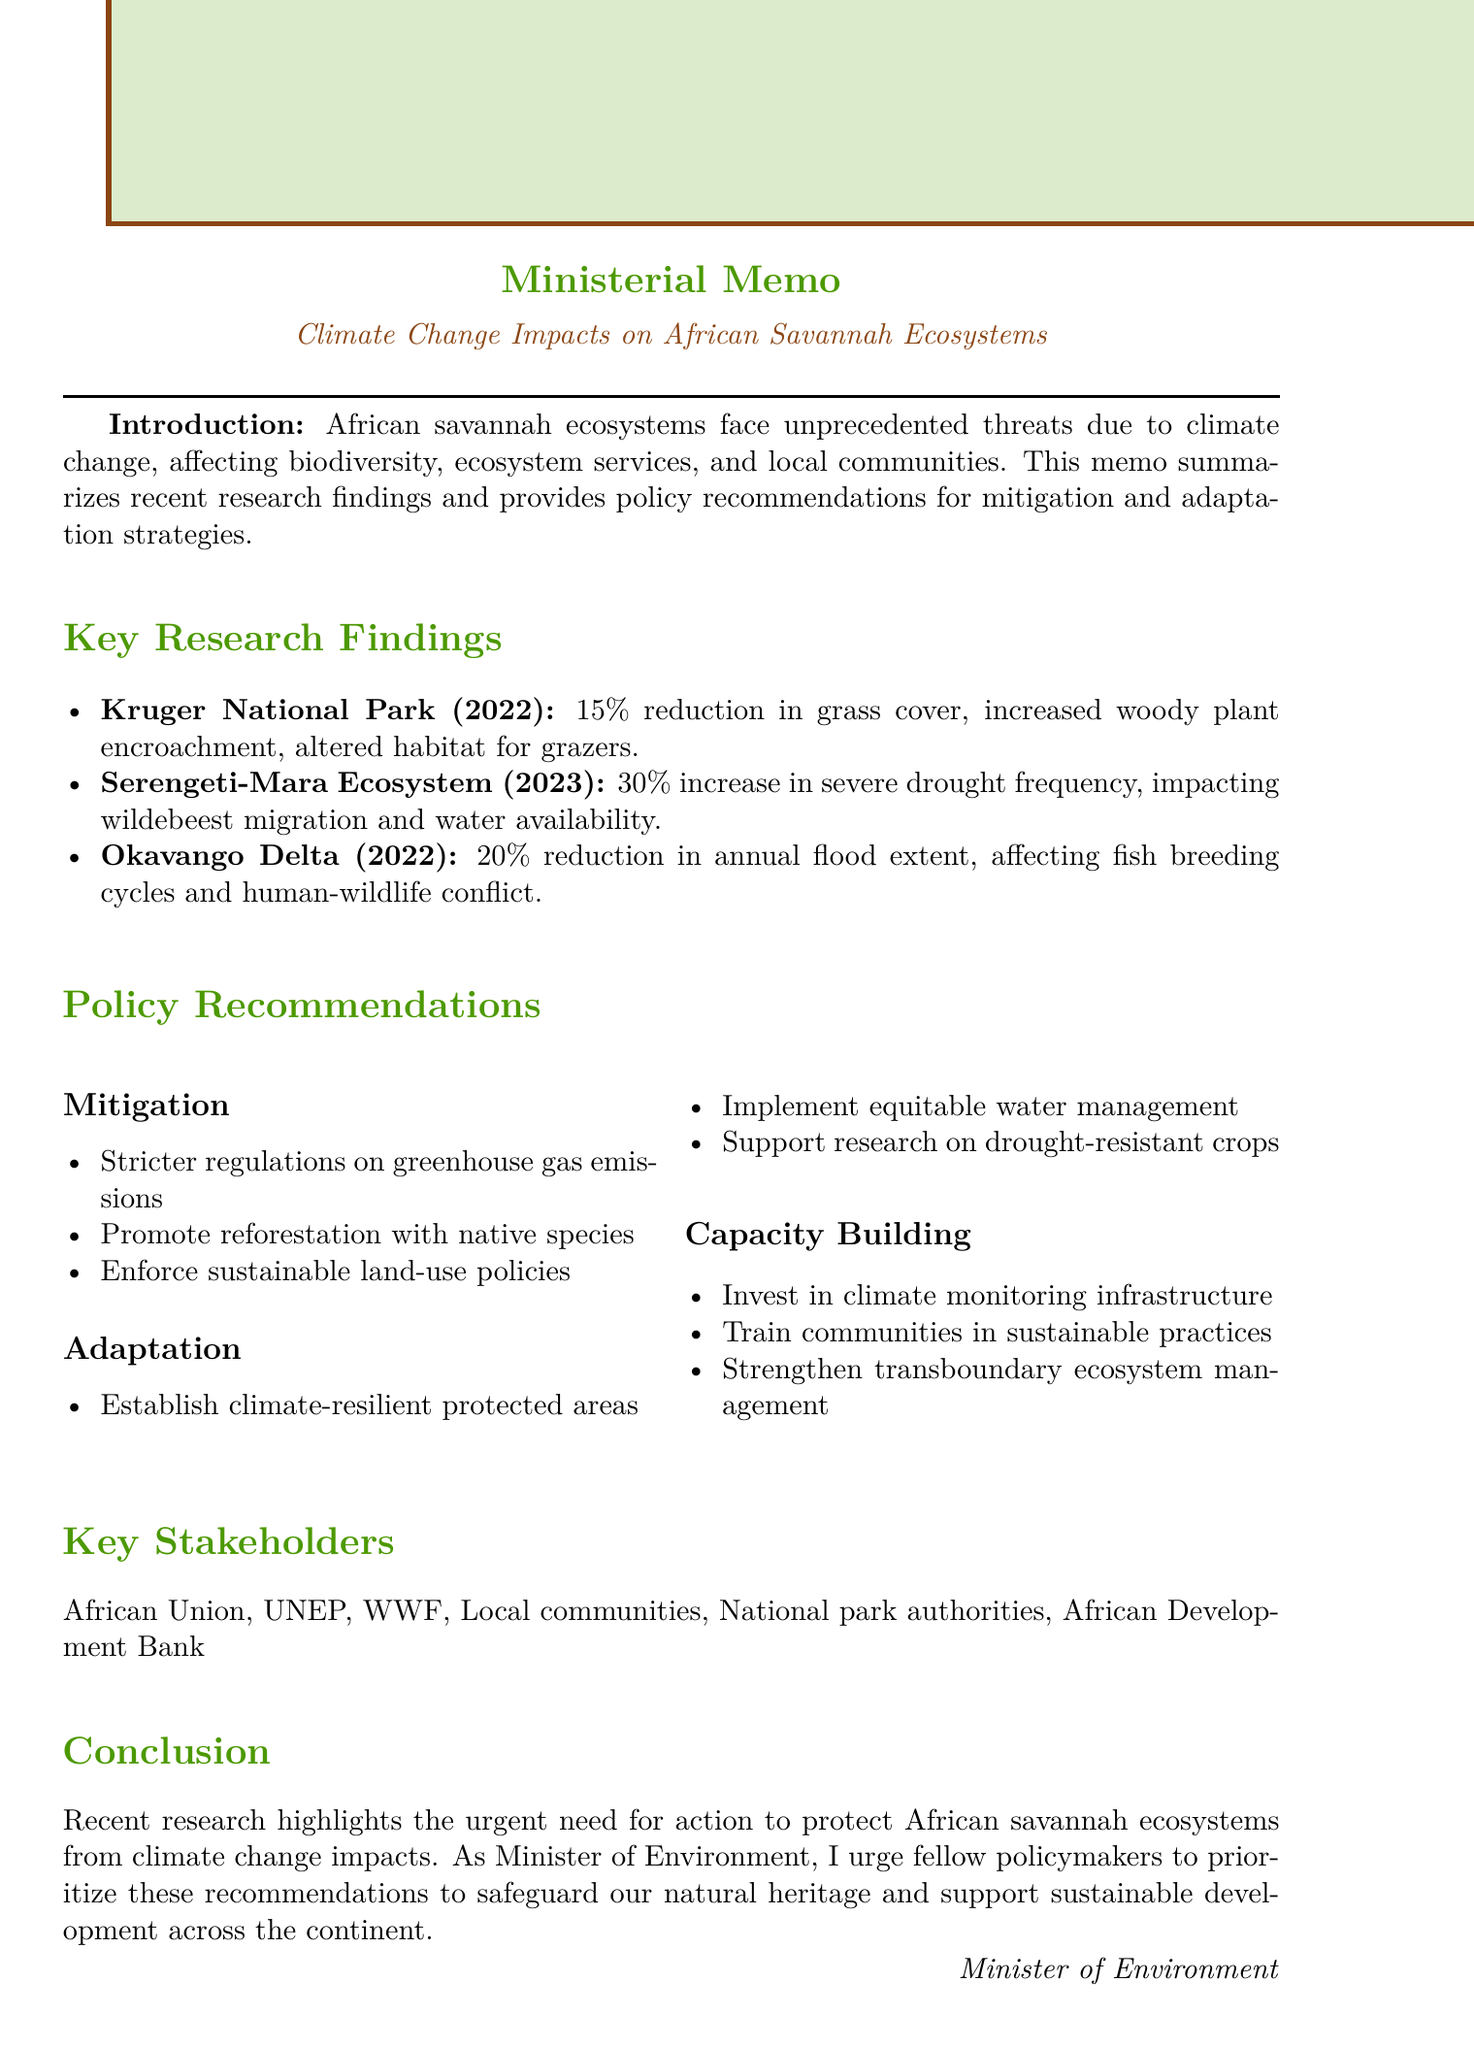What is the title of the memo? The title is clearly stated at the top of the memo.
Answer: Climate Change Impacts on African Savannah Ecosystems: Recent Research Findings and Policy Recommendations Who authored the study on the Kruger National Park? The authorship is listed under the key research findings section.
Answer: Dr. Thabo Molefi et al., University of Cape Town What percentage reduction in grass cover was reported in the Kruger National Park? The specific figure is provided under the key findings of the relevant study.
Answer: 15% What year was the study on drought patterns in the Serengeti-Mara ecosystem published? The publication year is mentioned alongside the study title in the document.
Answer: 2023 What is one of the proposed actions for adaptation in the policy recommendations? Adaptation actions are listed in their own subsection within the policy recommendations.
Answer: Establish climate-resilient protected areas How many stakeholders are listed in the document? The stakeholders are enumerated under the relevant section of the memo.
Answer: Six What is the main call to action stated in the conclusion? This statement encapsulates the urgency and direction provided in the conclusion section.
Answer: Prioritize the implementation of these recommendations What is a major environmental change observed in the Okavango Delta? The key findings section lists significant changes associated with each study.
Answer: 20% reduction in annual flood extent What type of document is this memo classified as? The format and purpose of the document suggest its classification.
Answer: Ministerial Memo 